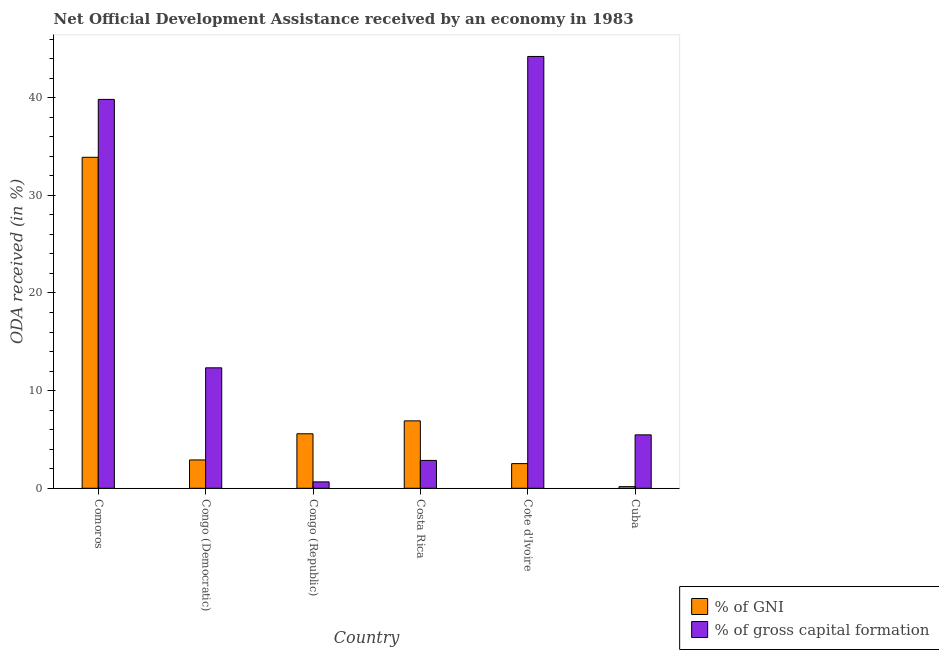How many groups of bars are there?
Ensure brevity in your answer.  6. Are the number of bars per tick equal to the number of legend labels?
Keep it short and to the point. Yes. Are the number of bars on each tick of the X-axis equal?
Offer a very short reply. Yes. How many bars are there on the 4th tick from the left?
Offer a very short reply. 2. What is the label of the 2nd group of bars from the left?
Provide a short and direct response. Congo (Democratic). What is the oda received as percentage of gross capital formation in Costa Rica?
Make the answer very short. 2.85. Across all countries, what is the maximum oda received as percentage of gni?
Your answer should be very brief. 33.9. Across all countries, what is the minimum oda received as percentage of gni?
Keep it short and to the point. 0.17. In which country was the oda received as percentage of gni maximum?
Offer a terse response. Comoros. In which country was the oda received as percentage of gross capital formation minimum?
Make the answer very short. Congo (Republic). What is the total oda received as percentage of gross capital formation in the graph?
Your response must be concise. 105.36. What is the difference between the oda received as percentage of gni in Comoros and that in Cuba?
Provide a succinct answer. 33.73. What is the difference between the oda received as percentage of gni in Cuba and the oda received as percentage of gross capital formation in Congo (Democratic)?
Keep it short and to the point. -12.17. What is the average oda received as percentage of gross capital formation per country?
Make the answer very short. 17.56. What is the difference between the oda received as percentage of gross capital formation and oda received as percentage of gni in Comoros?
Give a very brief answer. 5.93. In how many countries, is the oda received as percentage of gross capital formation greater than 30 %?
Your response must be concise. 2. What is the ratio of the oda received as percentage of gross capital formation in Costa Rica to that in Cote d'Ivoire?
Give a very brief answer. 0.06. Is the difference between the oda received as percentage of gni in Cote d'Ivoire and Cuba greater than the difference between the oda received as percentage of gross capital formation in Cote d'Ivoire and Cuba?
Your answer should be very brief. No. What is the difference between the highest and the second highest oda received as percentage of gross capital formation?
Your answer should be compact. 4.4. What is the difference between the highest and the lowest oda received as percentage of gni?
Offer a very short reply. 33.73. In how many countries, is the oda received as percentage of gni greater than the average oda received as percentage of gni taken over all countries?
Provide a short and direct response. 1. What does the 2nd bar from the left in Comoros represents?
Make the answer very short. % of gross capital formation. What does the 2nd bar from the right in Congo (Democratic) represents?
Make the answer very short. % of GNI. How many bars are there?
Ensure brevity in your answer.  12. Are all the bars in the graph horizontal?
Provide a succinct answer. No. How many countries are there in the graph?
Keep it short and to the point. 6. Are the values on the major ticks of Y-axis written in scientific E-notation?
Offer a very short reply. No. Does the graph contain any zero values?
Your answer should be compact. No. Does the graph contain grids?
Keep it short and to the point. No. Where does the legend appear in the graph?
Offer a very short reply. Bottom right. How are the legend labels stacked?
Your response must be concise. Vertical. What is the title of the graph?
Your answer should be compact. Net Official Development Assistance received by an economy in 1983. What is the label or title of the Y-axis?
Give a very brief answer. ODA received (in %). What is the ODA received (in %) of % of GNI in Comoros?
Your answer should be compact. 33.9. What is the ODA received (in %) of % of gross capital formation in Comoros?
Make the answer very short. 39.82. What is the ODA received (in %) of % of GNI in Congo (Democratic)?
Keep it short and to the point. 2.9. What is the ODA received (in %) in % of gross capital formation in Congo (Democratic)?
Provide a succinct answer. 12.34. What is the ODA received (in %) in % of GNI in Congo (Republic)?
Offer a terse response. 5.58. What is the ODA received (in %) of % of gross capital formation in Congo (Republic)?
Your answer should be compact. 0.65. What is the ODA received (in %) in % of GNI in Costa Rica?
Your response must be concise. 6.9. What is the ODA received (in %) of % of gross capital formation in Costa Rica?
Ensure brevity in your answer.  2.85. What is the ODA received (in %) of % of GNI in Cote d'Ivoire?
Offer a terse response. 2.53. What is the ODA received (in %) of % of gross capital formation in Cote d'Ivoire?
Offer a very short reply. 44.22. What is the ODA received (in %) of % of GNI in Cuba?
Ensure brevity in your answer.  0.17. What is the ODA received (in %) of % of gross capital formation in Cuba?
Provide a short and direct response. 5.47. Across all countries, what is the maximum ODA received (in %) of % of GNI?
Offer a terse response. 33.9. Across all countries, what is the maximum ODA received (in %) in % of gross capital formation?
Your answer should be compact. 44.22. Across all countries, what is the minimum ODA received (in %) of % of GNI?
Give a very brief answer. 0.17. Across all countries, what is the minimum ODA received (in %) of % of gross capital formation?
Your answer should be compact. 0.65. What is the total ODA received (in %) in % of GNI in the graph?
Your answer should be compact. 51.98. What is the total ODA received (in %) of % of gross capital formation in the graph?
Give a very brief answer. 105.36. What is the difference between the ODA received (in %) of % of GNI in Comoros and that in Congo (Democratic)?
Offer a terse response. 30.99. What is the difference between the ODA received (in %) of % of gross capital formation in Comoros and that in Congo (Democratic)?
Your answer should be very brief. 27.49. What is the difference between the ODA received (in %) in % of GNI in Comoros and that in Congo (Republic)?
Offer a terse response. 28.31. What is the difference between the ODA received (in %) of % of gross capital formation in Comoros and that in Congo (Republic)?
Your response must be concise. 39.17. What is the difference between the ODA received (in %) in % of GNI in Comoros and that in Costa Rica?
Your answer should be compact. 26.99. What is the difference between the ODA received (in %) in % of gross capital formation in Comoros and that in Costa Rica?
Provide a short and direct response. 36.97. What is the difference between the ODA received (in %) of % of GNI in Comoros and that in Cote d'Ivoire?
Provide a short and direct response. 31.37. What is the difference between the ODA received (in %) of % of gross capital formation in Comoros and that in Cote d'Ivoire?
Offer a very short reply. -4.4. What is the difference between the ODA received (in %) in % of GNI in Comoros and that in Cuba?
Offer a terse response. 33.73. What is the difference between the ODA received (in %) of % of gross capital formation in Comoros and that in Cuba?
Your answer should be compact. 34.35. What is the difference between the ODA received (in %) of % of GNI in Congo (Democratic) and that in Congo (Republic)?
Keep it short and to the point. -2.68. What is the difference between the ODA received (in %) in % of gross capital formation in Congo (Democratic) and that in Congo (Republic)?
Provide a short and direct response. 11.68. What is the difference between the ODA received (in %) in % of GNI in Congo (Democratic) and that in Costa Rica?
Make the answer very short. -4. What is the difference between the ODA received (in %) of % of gross capital formation in Congo (Democratic) and that in Costa Rica?
Provide a short and direct response. 9.48. What is the difference between the ODA received (in %) of % of GNI in Congo (Democratic) and that in Cote d'Ivoire?
Give a very brief answer. 0.38. What is the difference between the ODA received (in %) of % of gross capital formation in Congo (Democratic) and that in Cote d'Ivoire?
Ensure brevity in your answer.  -31.88. What is the difference between the ODA received (in %) of % of GNI in Congo (Democratic) and that in Cuba?
Offer a terse response. 2.73. What is the difference between the ODA received (in %) of % of gross capital formation in Congo (Democratic) and that in Cuba?
Provide a succinct answer. 6.87. What is the difference between the ODA received (in %) of % of GNI in Congo (Republic) and that in Costa Rica?
Give a very brief answer. -1.32. What is the difference between the ODA received (in %) of % of gross capital formation in Congo (Republic) and that in Costa Rica?
Provide a succinct answer. -2.2. What is the difference between the ODA received (in %) of % of GNI in Congo (Republic) and that in Cote d'Ivoire?
Offer a very short reply. 3.06. What is the difference between the ODA received (in %) in % of gross capital formation in Congo (Republic) and that in Cote d'Ivoire?
Provide a succinct answer. -43.57. What is the difference between the ODA received (in %) in % of GNI in Congo (Republic) and that in Cuba?
Keep it short and to the point. 5.41. What is the difference between the ODA received (in %) in % of gross capital formation in Congo (Republic) and that in Cuba?
Your answer should be compact. -4.82. What is the difference between the ODA received (in %) in % of GNI in Costa Rica and that in Cote d'Ivoire?
Your answer should be compact. 4.38. What is the difference between the ODA received (in %) in % of gross capital formation in Costa Rica and that in Cote d'Ivoire?
Your answer should be very brief. -41.37. What is the difference between the ODA received (in %) of % of GNI in Costa Rica and that in Cuba?
Offer a very short reply. 6.74. What is the difference between the ODA received (in %) of % of gross capital formation in Costa Rica and that in Cuba?
Provide a short and direct response. -2.62. What is the difference between the ODA received (in %) in % of GNI in Cote d'Ivoire and that in Cuba?
Ensure brevity in your answer.  2.36. What is the difference between the ODA received (in %) of % of gross capital formation in Cote d'Ivoire and that in Cuba?
Ensure brevity in your answer.  38.75. What is the difference between the ODA received (in %) in % of GNI in Comoros and the ODA received (in %) in % of gross capital formation in Congo (Democratic)?
Give a very brief answer. 21.56. What is the difference between the ODA received (in %) in % of GNI in Comoros and the ODA received (in %) in % of gross capital formation in Congo (Republic)?
Keep it short and to the point. 33.24. What is the difference between the ODA received (in %) of % of GNI in Comoros and the ODA received (in %) of % of gross capital formation in Costa Rica?
Keep it short and to the point. 31.04. What is the difference between the ODA received (in %) of % of GNI in Comoros and the ODA received (in %) of % of gross capital formation in Cote d'Ivoire?
Provide a short and direct response. -10.32. What is the difference between the ODA received (in %) in % of GNI in Comoros and the ODA received (in %) in % of gross capital formation in Cuba?
Provide a succinct answer. 28.43. What is the difference between the ODA received (in %) in % of GNI in Congo (Democratic) and the ODA received (in %) in % of gross capital formation in Congo (Republic)?
Provide a succinct answer. 2.25. What is the difference between the ODA received (in %) of % of GNI in Congo (Democratic) and the ODA received (in %) of % of gross capital formation in Costa Rica?
Keep it short and to the point. 0.05. What is the difference between the ODA received (in %) in % of GNI in Congo (Democratic) and the ODA received (in %) in % of gross capital formation in Cote d'Ivoire?
Your answer should be very brief. -41.32. What is the difference between the ODA received (in %) in % of GNI in Congo (Democratic) and the ODA received (in %) in % of gross capital formation in Cuba?
Your answer should be compact. -2.57. What is the difference between the ODA received (in %) of % of GNI in Congo (Republic) and the ODA received (in %) of % of gross capital formation in Costa Rica?
Ensure brevity in your answer.  2.73. What is the difference between the ODA received (in %) in % of GNI in Congo (Republic) and the ODA received (in %) in % of gross capital formation in Cote d'Ivoire?
Ensure brevity in your answer.  -38.64. What is the difference between the ODA received (in %) of % of GNI in Congo (Republic) and the ODA received (in %) of % of gross capital formation in Cuba?
Offer a terse response. 0.11. What is the difference between the ODA received (in %) in % of GNI in Costa Rica and the ODA received (in %) in % of gross capital formation in Cote d'Ivoire?
Give a very brief answer. -37.32. What is the difference between the ODA received (in %) in % of GNI in Costa Rica and the ODA received (in %) in % of gross capital formation in Cuba?
Give a very brief answer. 1.43. What is the difference between the ODA received (in %) in % of GNI in Cote d'Ivoire and the ODA received (in %) in % of gross capital formation in Cuba?
Provide a short and direct response. -2.95. What is the average ODA received (in %) in % of GNI per country?
Offer a very short reply. 8.66. What is the average ODA received (in %) of % of gross capital formation per country?
Give a very brief answer. 17.56. What is the difference between the ODA received (in %) in % of GNI and ODA received (in %) in % of gross capital formation in Comoros?
Your response must be concise. -5.93. What is the difference between the ODA received (in %) in % of GNI and ODA received (in %) in % of gross capital formation in Congo (Democratic)?
Make the answer very short. -9.43. What is the difference between the ODA received (in %) of % of GNI and ODA received (in %) of % of gross capital formation in Congo (Republic)?
Offer a very short reply. 4.93. What is the difference between the ODA received (in %) of % of GNI and ODA received (in %) of % of gross capital formation in Costa Rica?
Keep it short and to the point. 4.05. What is the difference between the ODA received (in %) of % of GNI and ODA received (in %) of % of gross capital formation in Cote d'Ivoire?
Your answer should be compact. -41.69. What is the difference between the ODA received (in %) of % of GNI and ODA received (in %) of % of gross capital formation in Cuba?
Provide a short and direct response. -5.3. What is the ratio of the ODA received (in %) in % of GNI in Comoros to that in Congo (Democratic)?
Your response must be concise. 11.68. What is the ratio of the ODA received (in %) of % of gross capital formation in Comoros to that in Congo (Democratic)?
Ensure brevity in your answer.  3.23. What is the ratio of the ODA received (in %) of % of GNI in Comoros to that in Congo (Republic)?
Provide a short and direct response. 6.07. What is the ratio of the ODA received (in %) in % of gross capital formation in Comoros to that in Congo (Republic)?
Make the answer very short. 60.82. What is the ratio of the ODA received (in %) in % of GNI in Comoros to that in Costa Rica?
Give a very brief answer. 4.91. What is the ratio of the ODA received (in %) of % of gross capital formation in Comoros to that in Costa Rica?
Your answer should be compact. 13.95. What is the ratio of the ODA received (in %) in % of GNI in Comoros to that in Cote d'Ivoire?
Give a very brief answer. 13.42. What is the ratio of the ODA received (in %) in % of gross capital formation in Comoros to that in Cote d'Ivoire?
Your response must be concise. 0.9. What is the ratio of the ODA received (in %) of % of GNI in Comoros to that in Cuba?
Your response must be concise. 200.44. What is the ratio of the ODA received (in %) in % of gross capital formation in Comoros to that in Cuba?
Provide a succinct answer. 7.28. What is the ratio of the ODA received (in %) of % of GNI in Congo (Democratic) to that in Congo (Republic)?
Make the answer very short. 0.52. What is the ratio of the ODA received (in %) in % of gross capital formation in Congo (Democratic) to that in Congo (Republic)?
Provide a succinct answer. 18.84. What is the ratio of the ODA received (in %) in % of GNI in Congo (Democratic) to that in Costa Rica?
Offer a very short reply. 0.42. What is the ratio of the ODA received (in %) in % of gross capital formation in Congo (Democratic) to that in Costa Rica?
Keep it short and to the point. 4.32. What is the ratio of the ODA received (in %) of % of GNI in Congo (Democratic) to that in Cote d'Ivoire?
Offer a terse response. 1.15. What is the ratio of the ODA received (in %) in % of gross capital formation in Congo (Democratic) to that in Cote d'Ivoire?
Ensure brevity in your answer.  0.28. What is the ratio of the ODA received (in %) in % of GNI in Congo (Democratic) to that in Cuba?
Provide a short and direct response. 17.16. What is the ratio of the ODA received (in %) in % of gross capital formation in Congo (Democratic) to that in Cuba?
Offer a very short reply. 2.25. What is the ratio of the ODA received (in %) in % of GNI in Congo (Republic) to that in Costa Rica?
Your response must be concise. 0.81. What is the ratio of the ODA received (in %) of % of gross capital formation in Congo (Republic) to that in Costa Rica?
Give a very brief answer. 0.23. What is the ratio of the ODA received (in %) of % of GNI in Congo (Republic) to that in Cote d'Ivoire?
Offer a very short reply. 2.21. What is the ratio of the ODA received (in %) in % of gross capital formation in Congo (Republic) to that in Cote d'Ivoire?
Make the answer very short. 0.01. What is the ratio of the ODA received (in %) in % of GNI in Congo (Republic) to that in Cuba?
Give a very brief answer. 33. What is the ratio of the ODA received (in %) in % of gross capital formation in Congo (Republic) to that in Cuba?
Your answer should be compact. 0.12. What is the ratio of the ODA received (in %) in % of GNI in Costa Rica to that in Cote d'Ivoire?
Provide a succinct answer. 2.73. What is the ratio of the ODA received (in %) in % of gross capital formation in Costa Rica to that in Cote d'Ivoire?
Keep it short and to the point. 0.06. What is the ratio of the ODA received (in %) in % of GNI in Costa Rica to that in Cuba?
Provide a succinct answer. 40.83. What is the ratio of the ODA received (in %) in % of gross capital formation in Costa Rica to that in Cuba?
Offer a very short reply. 0.52. What is the ratio of the ODA received (in %) of % of GNI in Cote d'Ivoire to that in Cuba?
Ensure brevity in your answer.  14.93. What is the ratio of the ODA received (in %) in % of gross capital formation in Cote d'Ivoire to that in Cuba?
Make the answer very short. 8.08. What is the difference between the highest and the second highest ODA received (in %) in % of GNI?
Ensure brevity in your answer.  26.99. What is the difference between the highest and the second highest ODA received (in %) of % of gross capital formation?
Provide a succinct answer. 4.4. What is the difference between the highest and the lowest ODA received (in %) of % of GNI?
Your answer should be compact. 33.73. What is the difference between the highest and the lowest ODA received (in %) in % of gross capital formation?
Your answer should be very brief. 43.57. 